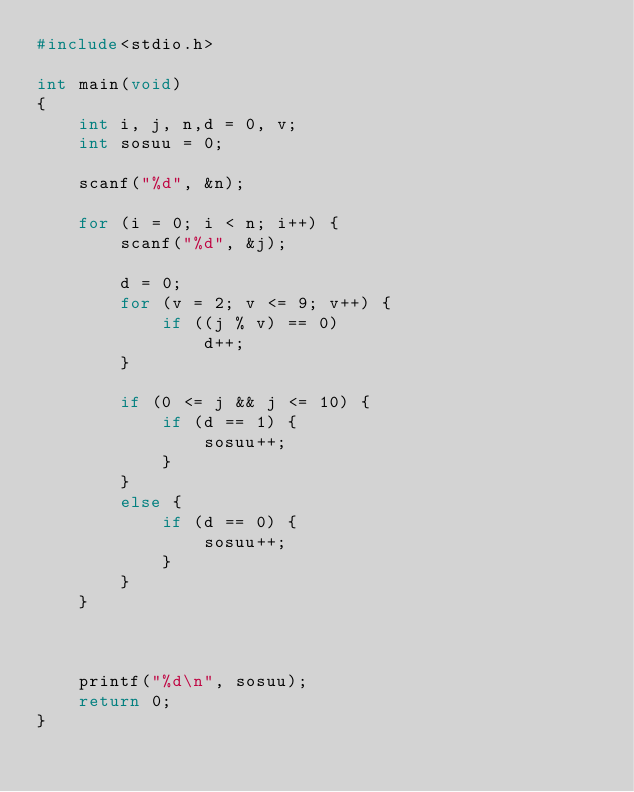<code> <loc_0><loc_0><loc_500><loc_500><_C_>#include<stdio.h>

int main(void)
{
	int i, j, n,d = 0, v;
	int sosuu = 0;

	scanf("%d", &n);

	for (i = 0; i < n; i++) {
		scanf("%d", &j);

		d = 0;
		for (v = 2; v <= 9; v++) {
			if ((j % v) == 0)
				d++;
		}

		if (0 <= j && j <= 10) {
			if (d == 1) {
				sosuu++;
			}
		}
		else {
			if (d == 0) {
				sosuu++;
			}
		}
	}

	

	printf("%d\n", sosuu);
	return 0;
}
</code> 